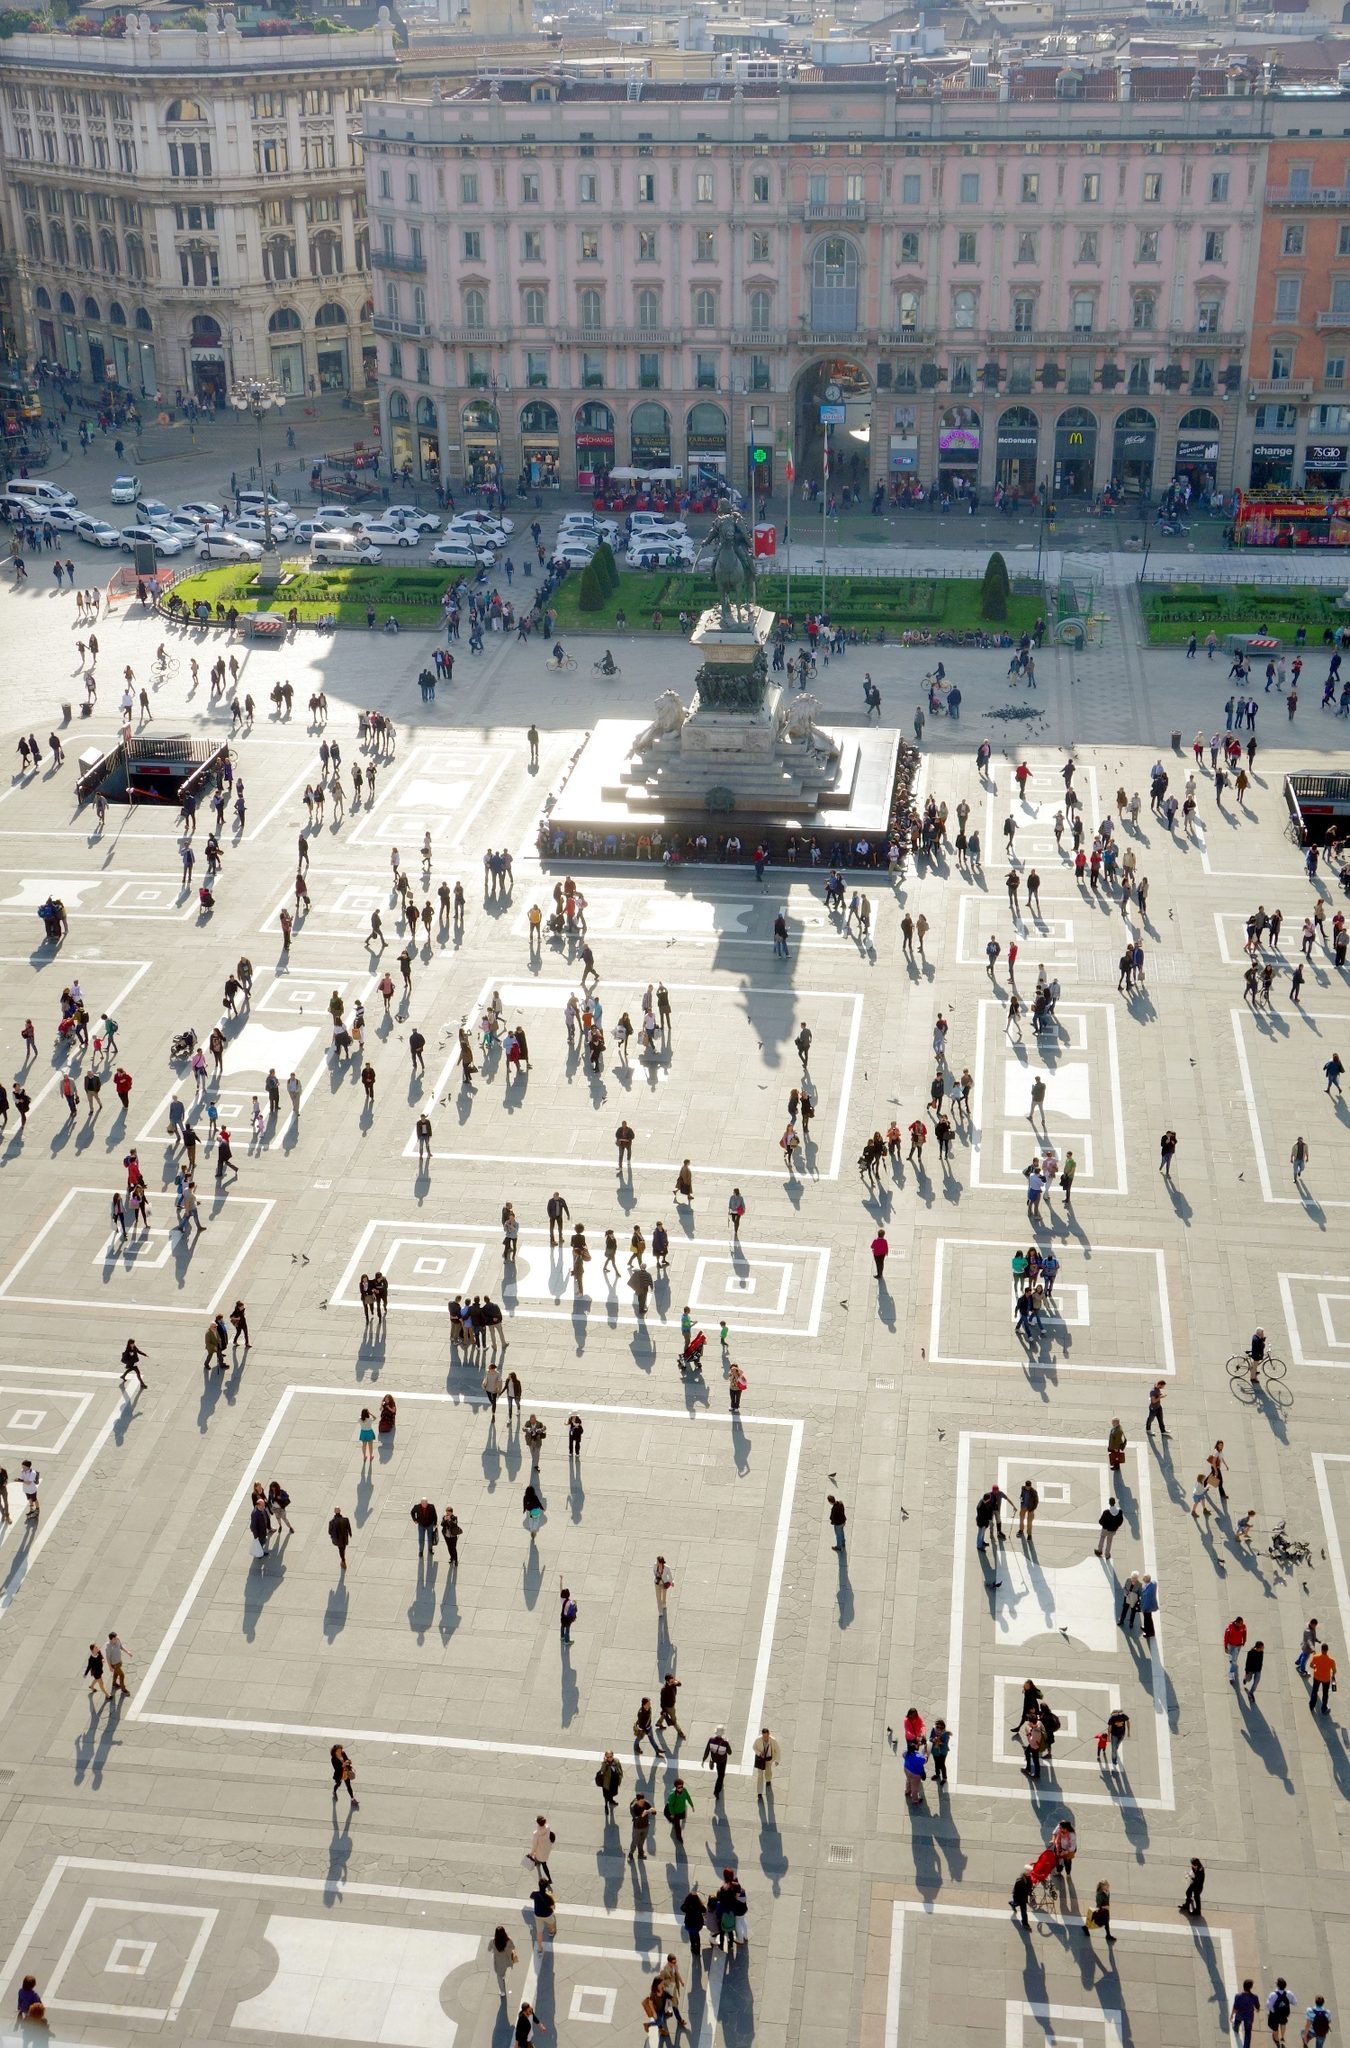Can you elaborate on the elements of the picture provided? The image presents a striking aerial view of the bustling Piazza del Duomo in Milan, Italy. Captured from the higher vantage point of the Duomo di Milano, the photograph offers a unique perspective on the vibrant square below, teeming with people and activity. Central to the image is the grand statue of Vittorio Emanuele II on horseback, majestically situated on a large pedestal. This iconic monument serves as a focal point, drawing the eye amid the lively crowd. Surrounding the square are beautifully ornate buildings, showcasing a blend of architectural styles with their detailed facades, arches, and columns, adding an air of historical elegance to the scene. The time of day, likely late afternoon, is marked by the long, dramatic shadows cast by the sun, lending depth and contrast to the overall composition. The shadows accentuate the geometric patterns on the pavement, highlighting the organized layout of the square. The image code "sa_12386" may be indicative of the specific viewpoint or moment the photo was taken, capturing the essence and atmosphere of this iconic Milanese landmark. 